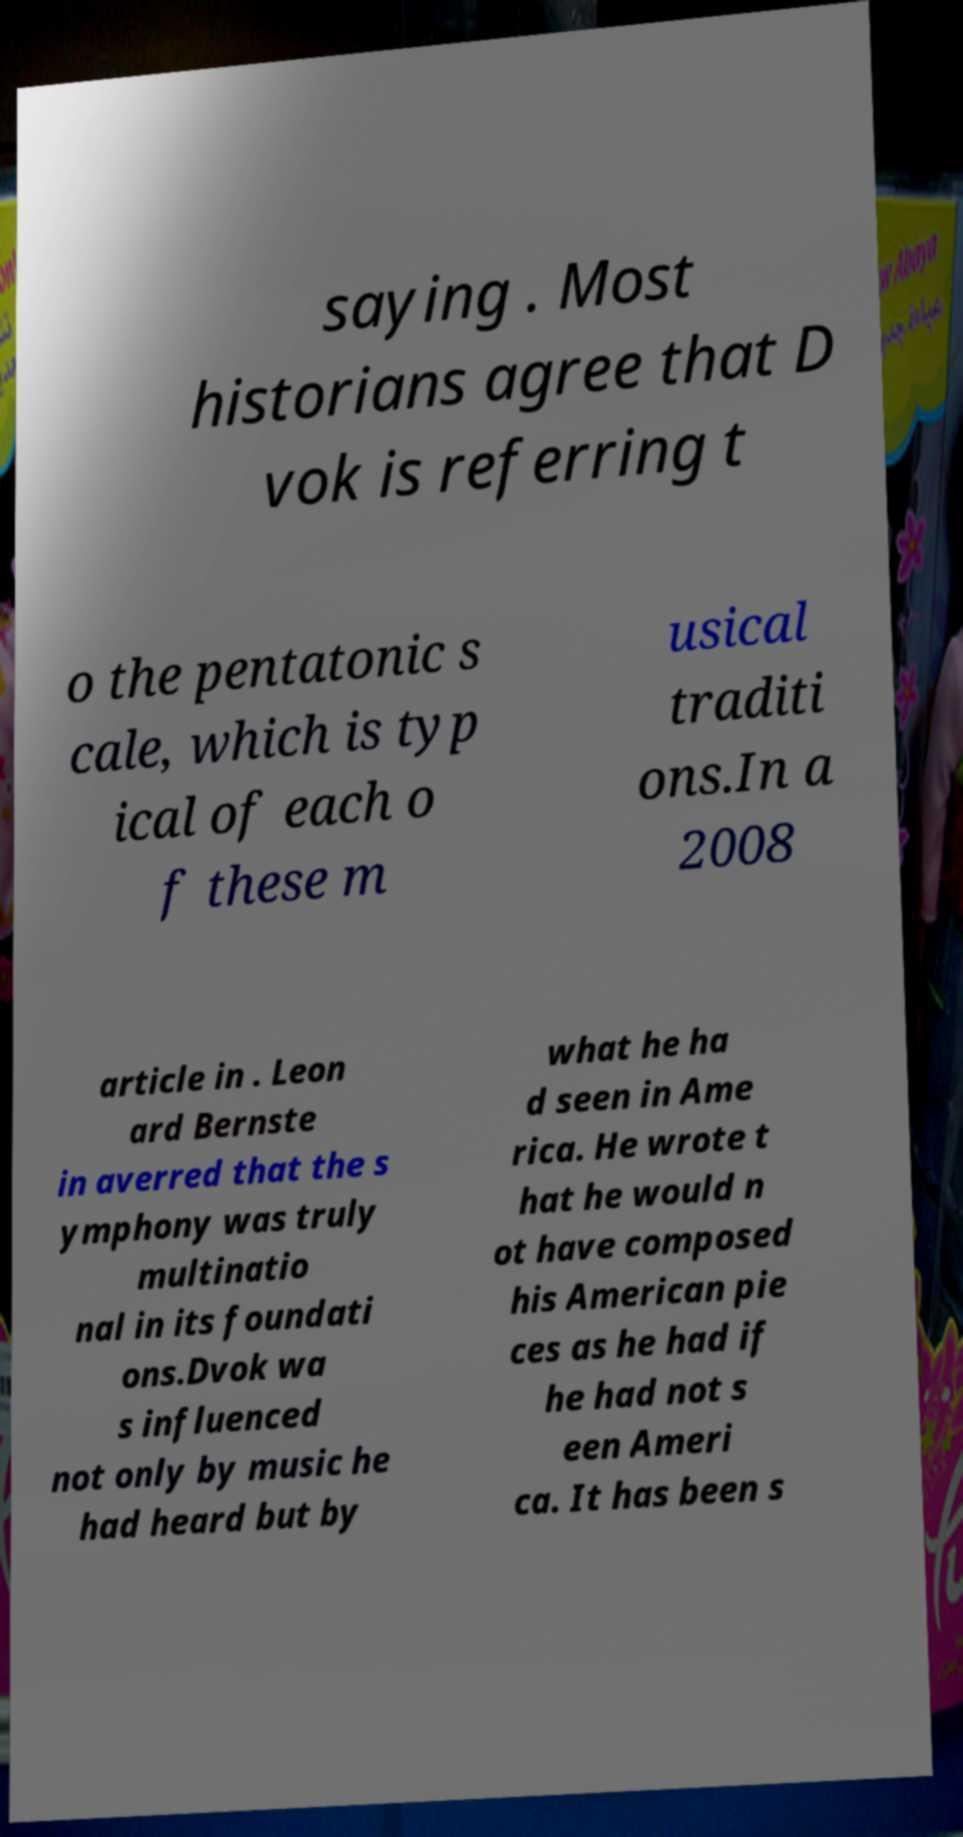Can you read and provide the text displayed in the image?This photo seems to have some interesting text. Can you extract and type it out for me? saying . Most historians agree that D vok is referring t o the pentatonic s cale, which is typ ical of each o f these m usical traditi ons.In a 2008 article in . Leon ard Bernste in averred that the s ymphony was truly multinatio nal in its foundati ons.Dvok wa s influenced not only by music he had heard but by what he ha d seen in Ame rica. He wrote t hat he would n ot have composed his American pie ces as he had if he had not s een Ameri ca. It has been s 